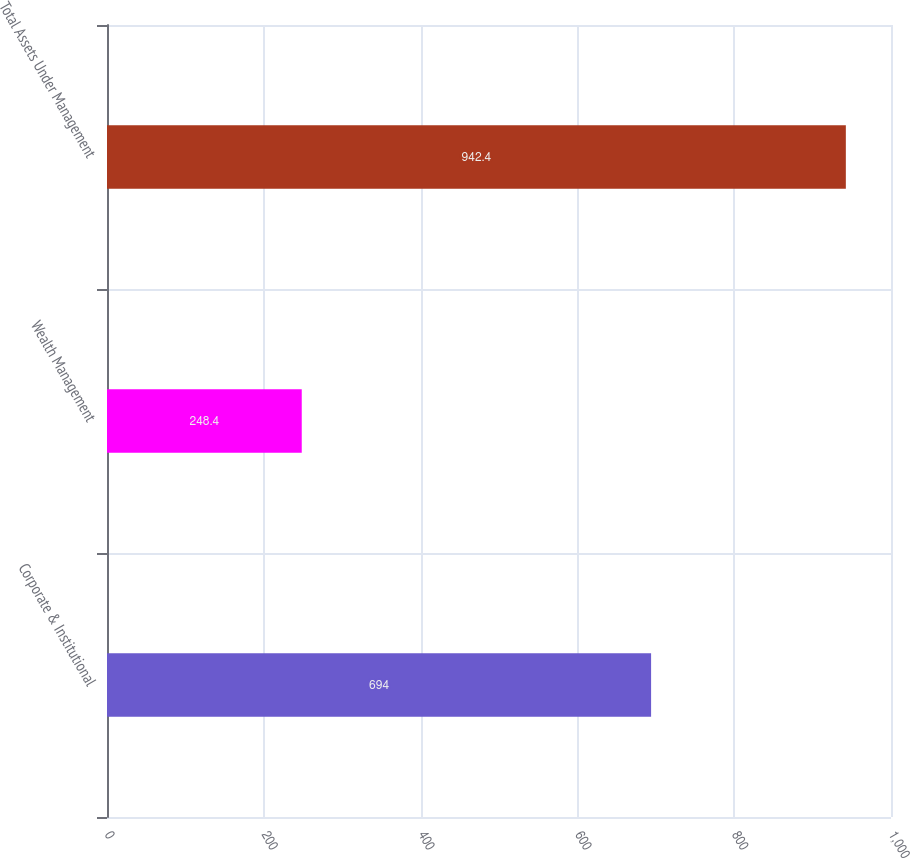Convert chart to OTSL. <chart><loc_0><loc_0><loc_500><loc_500><bar_chart><fcel>Corporate & Institutional<fcel>Wealth Management<fcel>Total Assets Under Management<nl><fcel>694<fcel>248.4<fcel>942.4<nl></chart> 